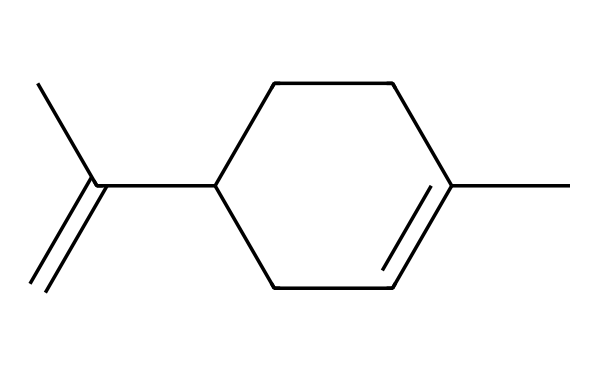How many carbon atoms are in limonene? The SMILES representation shows a total of 10 carbon atoms (C) in the structure, indicated by the 'C' symbols.
Answer: 10 What is the main functional group present in limonene? Limonene has a double bond in its structure, as evidenced by 'C(=C)', indicating the presence of an alkene functional group.
Answer: alkene What type of isomerism exists in limonene? The presence of a double bond (C=C) allows for geometrical isomerism (cis/trans), as the arrangement around the double bond can vary.
Answer: geometrical isomerism What cyclic structure is found in limonene? The 'C1' notation in the SMILES indicates a cycloalkane structure; specifically, there is a cyclohexane ring in the limonene molecule.
Answer: cyclohexane How many double bonds are present in limonene? The structure contains one double bond, which can be identified at 'C(=C)'.
Answer: 1 What type of terpene is limonene classified as? Limonene is classified as a monoterpene because it consists of two isoprene units (10 carbons total).
Answer: monoterpene 